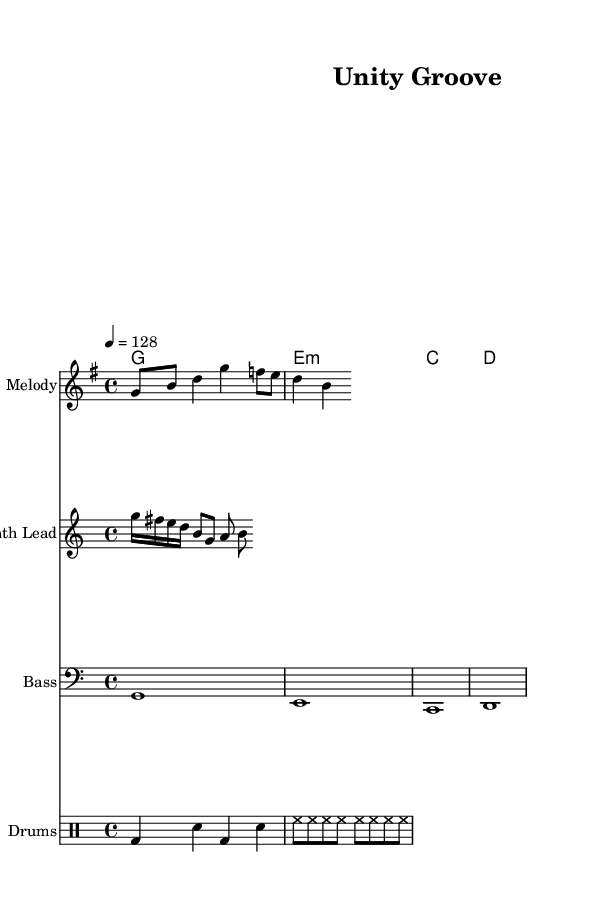What is the key signature of this music? The key signature is G major, which has one sharp (F#). It can be identified by looking for the sharp sign in the key signature section at the beginning of the staff.
Answer: G major What is the time signature of this music? The time signature indicated is 4/4, which means there are four beats in each measure and the quarter note gets one beat. This can be determined by the numbers immediately following the clef at the start of the score.
Answer: 4/4 What is the tempo marking for this piece? The tempo marking is quarter note equals 128 beats per minute, which specifies the pace of the music. This is indicated at the start of the score after the time signature.
Answer: 128 How many measures are in the melody section? The melody section contains four measures. This can be counted by looking at the number of vertical lines (bar lines) in the melody staff, with each line separating measures.
Answer: 4 Which chords are used in the harmonies? The chords used are G, E minor, C, and D. These can be read from the chord symbols above the melody, directly naming the chords played throughout the piece.
Answer: G, E minor, C, D What type of instrumentation is used in this piece? The instrumentation used includes melody, synth lead, bass, and drums. By identifying the different staff names in the score, one can recognize the various parts arranged for this K-Pop track.
Answer: Melody, Synth Lead, Bass, Drums What rhythmic pattern is depicted in the drum section? The drum section shows a pattern involving bass drums and snare on the first measure, followed by a hi-hat pattern in the second measure. This can be analyzed by looking at the drum notation, where each type of drum is represented by specific symbols.
Answer: Bass, Snare, Hi-Hat pattern 